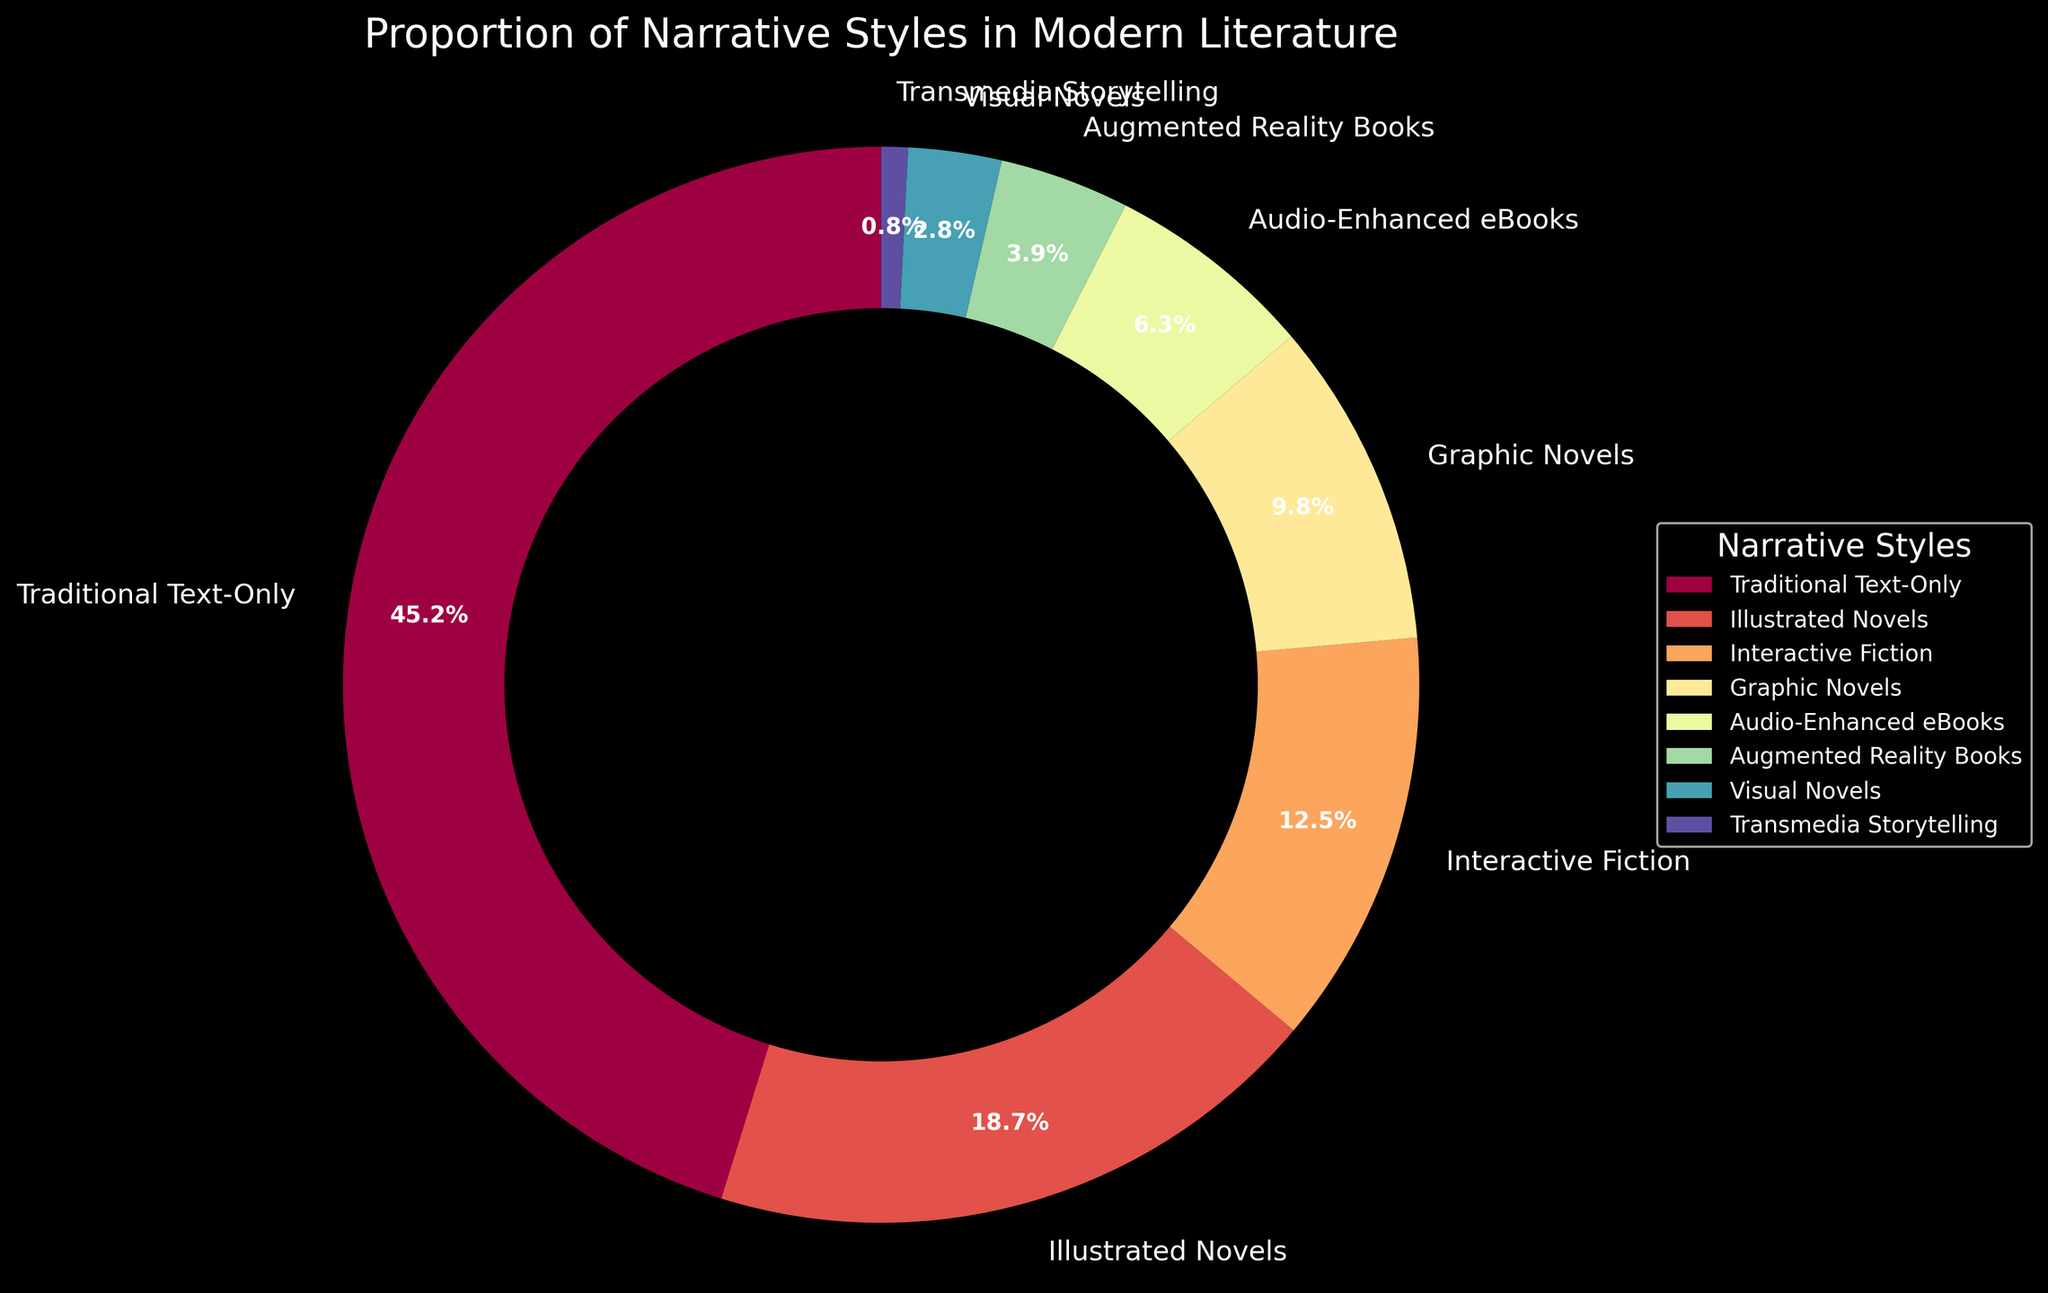What percentage of narrative styles incorporate multimedia elements? To determine the percentage of styles incorporating multimedia elements, sum all categories except "Traditional Text-Only". These contribute to the multimedia incorporation. This includes percentages for Illustrated Novels, Interactive Fiction, Graphic Novels, Audio-Enhanced eBooks, Augmented Reality Books, Visual Novels, and Transmedia Storytelling. Summing these up: 18.7 + 12.5 + 9.8 + 6.3 + 3.9 + 2.8 + 0.8 = 54.8%. So, 54.8% of narrative styles use multimedia elements.
Answer: 54.8% Which narrative style has the smallest proportion? Identify the smallest segment by looking at the pie chart. Transmedia Storytelling holds the smallest proportion at 0.8%.
Answer: Transmedia Storytelling Compare the proportions of Interactive Fiction and Graphic Novels. Which has a higher proportion and by how much? Interactive Fiction is 12.5% and Graphic Novels are 9.8%. Subtract the percentage of Graphic Novels from Interactive Fiction: 12.5% - 9.8% = 2.7%. Interactive Fiction has a higher proportion by 2.7%.
Answer: Interactive Fiction by 2.7% What is the combined percentage of Illustrated Novels and Graphic Novels? Add the percentages of Illustrated Novels and Graphic Novels: 18.7% + 9.8% = 28.5%. The combined percentage is 28.5%.
Answer: 28.5% How does the proportion of Audio-Enhanced eBooks compare to the Traditional Text-Only narrative style? The percentage for Audio-Enhanced eBooks is 6.3%, and for Traditional Text-Only it is 45.2%. Traditional Text-Only is larger. Traditional Text-Only is 45.2% - 6.3% = 38.9% more prevalent.
Answer: Traditional Text-Only by 38.9% What is the difference in proportion between the most and least common narrative styles that incorporate multimedia? The most common multimedia narrative style is Illustrated Novels at 18.7%, and the least common is Transmedia Storytelling at 0.8%. The difference is 18.7% - 0.8% = 17.9%.
Answer: 17.9% Identify the narrative styles with proportions greater than 10%. Look at the segments of the pie chart with proportions over 10%. There are two: Traditional Text-Only at 45.2%, Illustrated Novels at 18.7%, and Interactive Fiction at 12.5%.
Answer: Traditional Text-Only, Illustrated Novels, Interactive Fiction If you combine the proportions of Augmented Reality Books and Visual Novels, how does their total compare to the proportion of Audio-Enhanced eBooks? First, sum the percentages of Augmented Reality Books (3.9%) and Visual Novels (2.8%): 3.9% + 2.8% = 6.7%. Compare this to Audio-Enhanced eBooks, which is 6.3%. Thus, their combined total is slightly higher by 0.4%.
Answer: Combined total is higher by 0.4% What proportion is represented by narrative styles other than Traditional Text-Only? Subtract the proportion of Traditional Text-Only from 100%: 100% - 45.2% = 54.8%. So, 54.8% is represented by narrative styles other than Traditional Text-Only.
Answer: 54.8% What percentage of narrative styles fall under the category of visual narratives (Illustrated Novels + Graphic Novels + Visual Novels)? Add the percentages of Illustrated Novels, Graphic Novels, and Visual Novels: 18.7% + 9.8% + 2.8% = 31.3%. The visual narratives constitute 31.3%.
Answer: 31.3% 